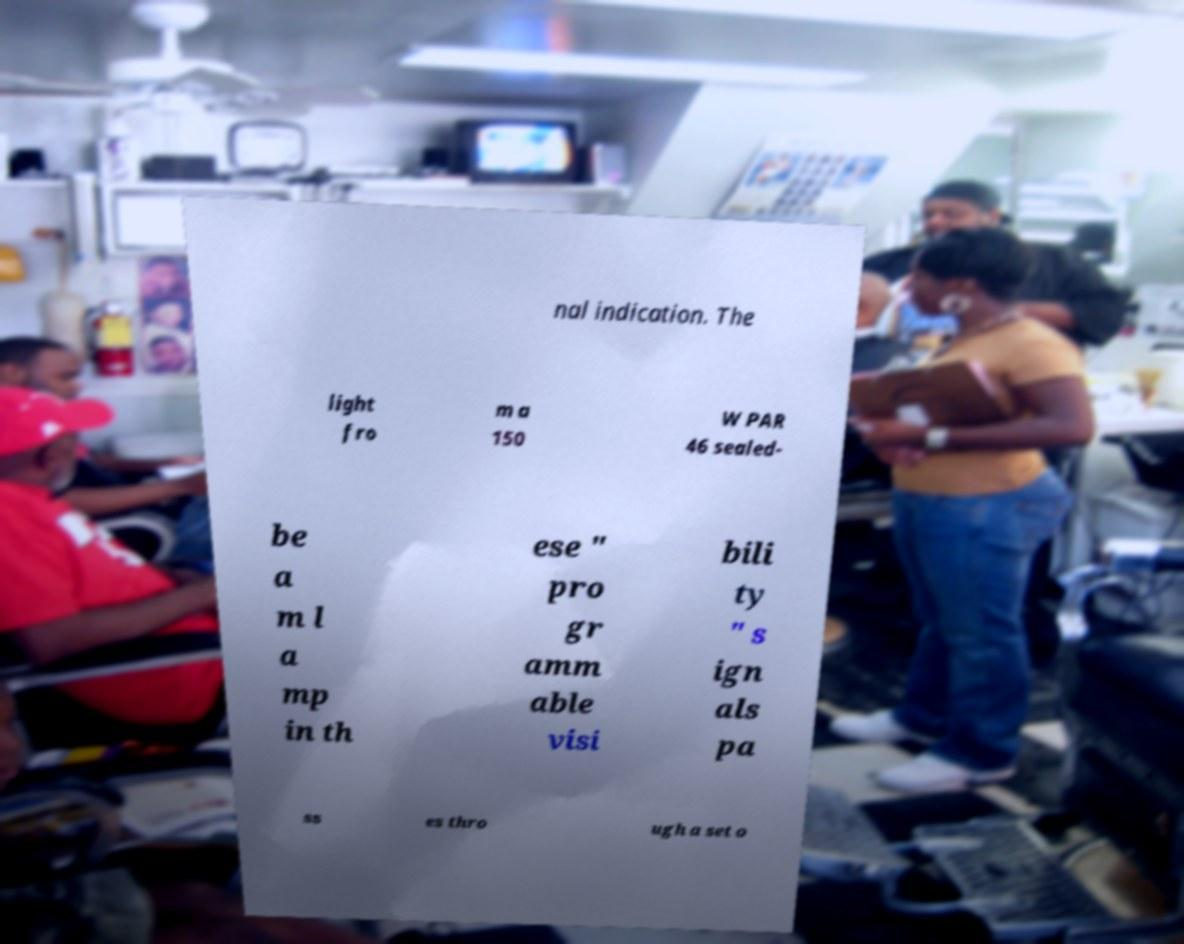For documentation purposes, I need the text within this image transcribed. Could you provide that? nal indication. The light fro m a 150 W PAR 46 sealed- be a m l a mp in th ese " pro gr amm able visi bili ty " s ign als pa ss es thro ugh a set o 